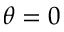<formula> <loc_0><loc_0><loc_500><loc_500>\theta = 0</formula> 